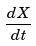<formula> <loc_0><loc_0><loc_500><loc_500>\frac { d X } { d t }</formula> 